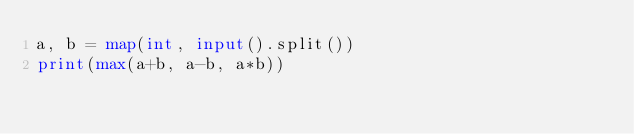<code> <loc_0><loc_0><loc_500><loc_500><_Python_>a, b = map(int, input().split())
print(max(a+b, a-b, a*b))</code> 